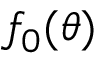Convert formula to latex. <formula><loc_0><loc_0><loc_500><loc_500>f _ { 0 } ( \theta )</formula> 